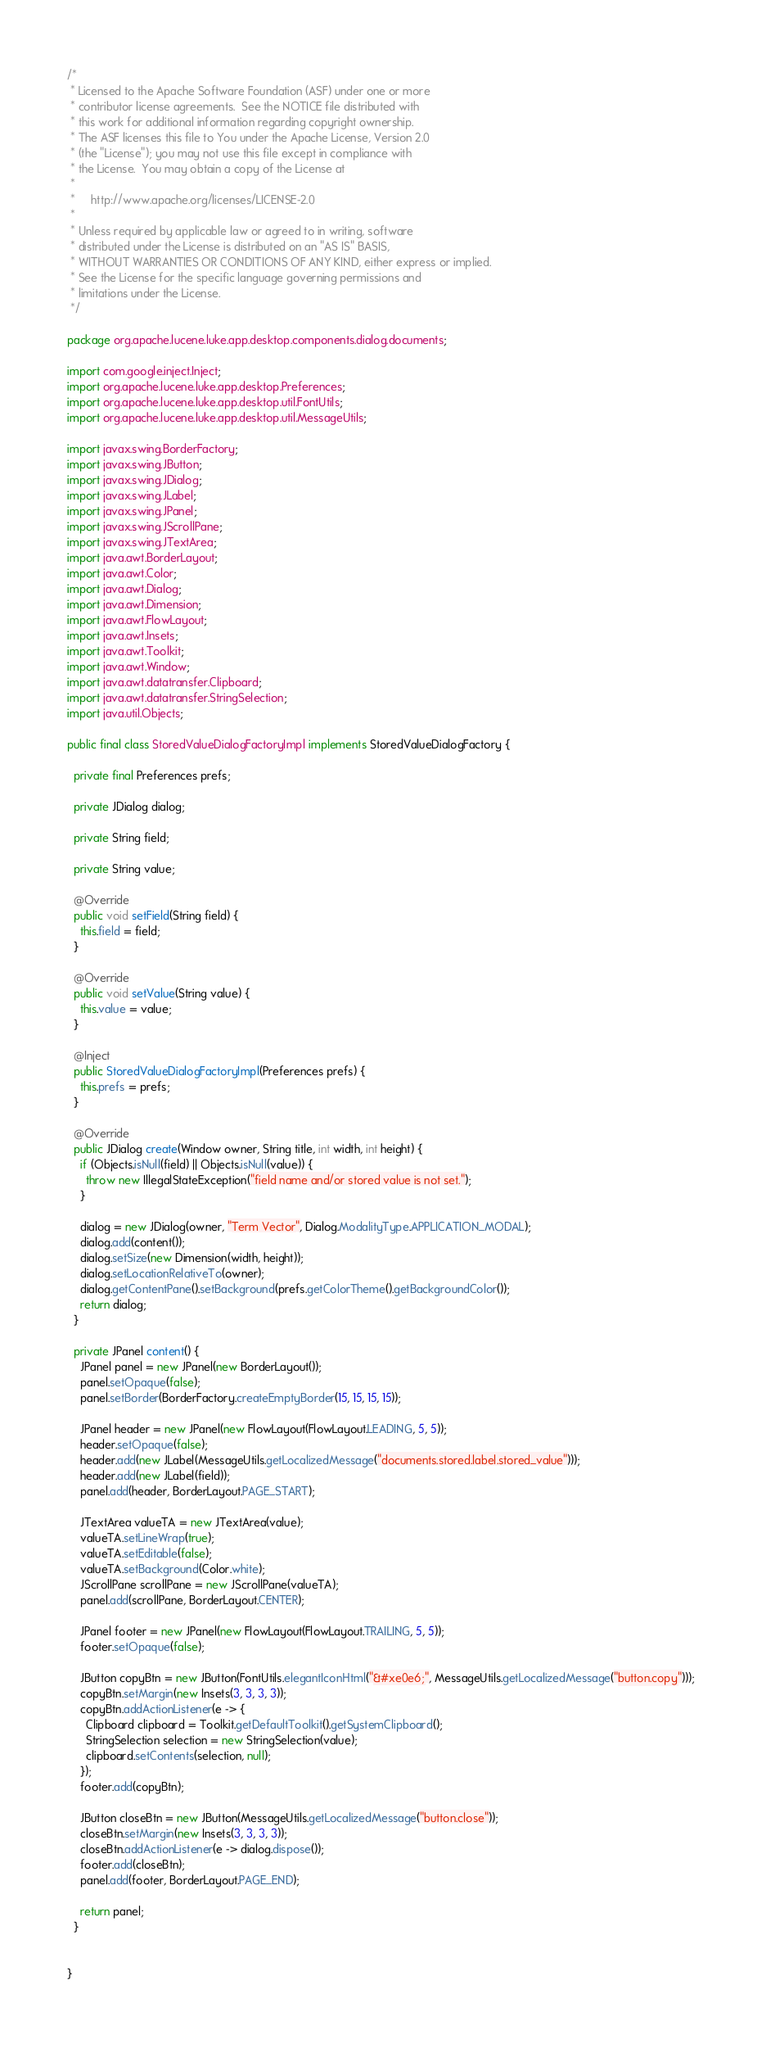<code> <loc_0><loc_0><loc_500><loc_500><_Java_>/*
 * Licensed to the Apache Software Foundation (ASF) under one or more
 * contributor license agreements.  See the NOTICE file distributed with
 * this work for additional information regarding copyright ownership.
 * The ASF licenses this file to You under the Apache License, Version 2.0
 * (the "License"); you may not use this file except in compliance with
 * the License.  You may obtain a copy of the License at
 *
 *     http://www.apache.org/licenses/LICENSE-2.0
 *
 * Unless required by applicable law or agreed to in writing, software
 * distributed under the License is distributed on an "AS IS" BASIS,
 * WITHOUT WARRANTIES OR CONDITIONS OF ANY KIND, either express or implied.
 * See the License for the specific language governing permissions and
 * limitations under the License.
 */

package org.apache.lucene.luke.app.desktop.components.dialog.documents;

import com.google.inject.Inject;
import org.apache.lucene.luke.app.desktop.Preferences;
import org.apache.lucene.luke.app.desktop.util.FontUtils;
import org.apache.lucene.luke.app.desktop.util.MessageUtils;

import javax.swing.BorderFactory;
import javax.swing.JButton;
import javax.swing.JDialog;
import javax.swing.JLabel;
import javax.swing.JPanel;
import javax.swing.JScrollPane;
import javax.swing.JTextArea;
import java.awt.BorderLayout;
import java.awt.Color;
import java.awt.Dialog;
import java.awt.Dimension;
import java.awt.FlowLayout;
import java.awt.Insets;
import java.awt.Toolkit;
import java.awt.Window;
import java.awt.datatransfer.Clipboard;
import java.awt.datatransfer.StringSelection;
import java.util.Objects;

public final class StoredValueDialogFactoryImpl implements StoredValueDialogFactory {

  private final Preferences prefs;

  private JDialog dialog;

  private String field;

  private String value;

  @Override
  public void setField(String field) {
    this.field = field;
  }

  @Override
  public void setValue(String value) {
    this.value = value;
  }

  @Inject
  public StoredValueDialogFactoryImpl(Preferences prefs) {
    this.prefs = prefs;
  }

  @Override
  public JDialog create(Window owner, String title, int width, int height) {
    if (Objects.isNull(field) || Objects.isNull(value)) {
      throw new IllegalStateException("field name and/or stored value is not set.");
    }

    dialog = new JDialog(owner, "Term Vector", Dialog.ModalityType.APPLICATION_MODAL);
    dialog.add(content());
    dialog.setSize(new Dimension(width, height));
    dialog.setLocationRelativeTo(owner);
    dialog.getContentPane().setBackground(prefs.getColorTheme().getBackgroundColor());
    return dialog;
  }

  private JPanel content() {
    JPanel panel = new JPanel(new BorderLayout());
    panel.setOpaque(false);
    panel.setBorder(BorderFactory.createEmptyBorder(15, 15, 15, 15));

    JPanel header = new JPanel(new FlowLayout(FlowLayout.LEADING, 5, 5));
    header.setOpaque(false);
    header.add(new JLabel(MessageUtils.getLocalizedMessage("documents.stored.label.stored_value")));
    header.add(new JLabel(field));
    panel.add(header, BorderLayout.PAGE_START);

    JTextArea valueTA = new JTextArea(value);
    valueTA.setLineWrap(true);
    valueTA.setEditable(false);
    valueTA.setBackground(Color.white);
    JScrollPane scrollPane = new JScrollPane(valueTA);
    panel.add(scrollPane, BorderLayout.CENTER);

    JPanel footer = new JPanel(new FlowLayout(FlowLayout.TRAILING, 5, 5));
    footer.setOpaque(false);

    JButton copyBtn = new JButton(FontUtils.elegantIconHtml("&#xe0e6;", MessageUtils.getLocalizedMessage("button.copy")));
    copyBtn.setMargin(new Insets(3, 3, 3, 3));
    copyBtn.addActionListener(e -> {
      Clipboard clipboard = Toolkit.getDefaultToolkit().getSystemClipboard();
      StringSelection selection = new StringSelection(value);
      clipboard.setContents(selection, null);
    });
    footer.add(copyBtn);

    JButton closeBtn = new JButton(MessageUtils.getLocalizedMessage("button.close"));
    closeBtn.setMargin(new Insets(3, 3, 3, 3));
    closeBtn.addActionListener(e -> dialog.dispose());
    footer.add(closeBtn);
    panel.add(footer, BorderLayout.PAGE_END);

    return panel;
  }


}
</code> 